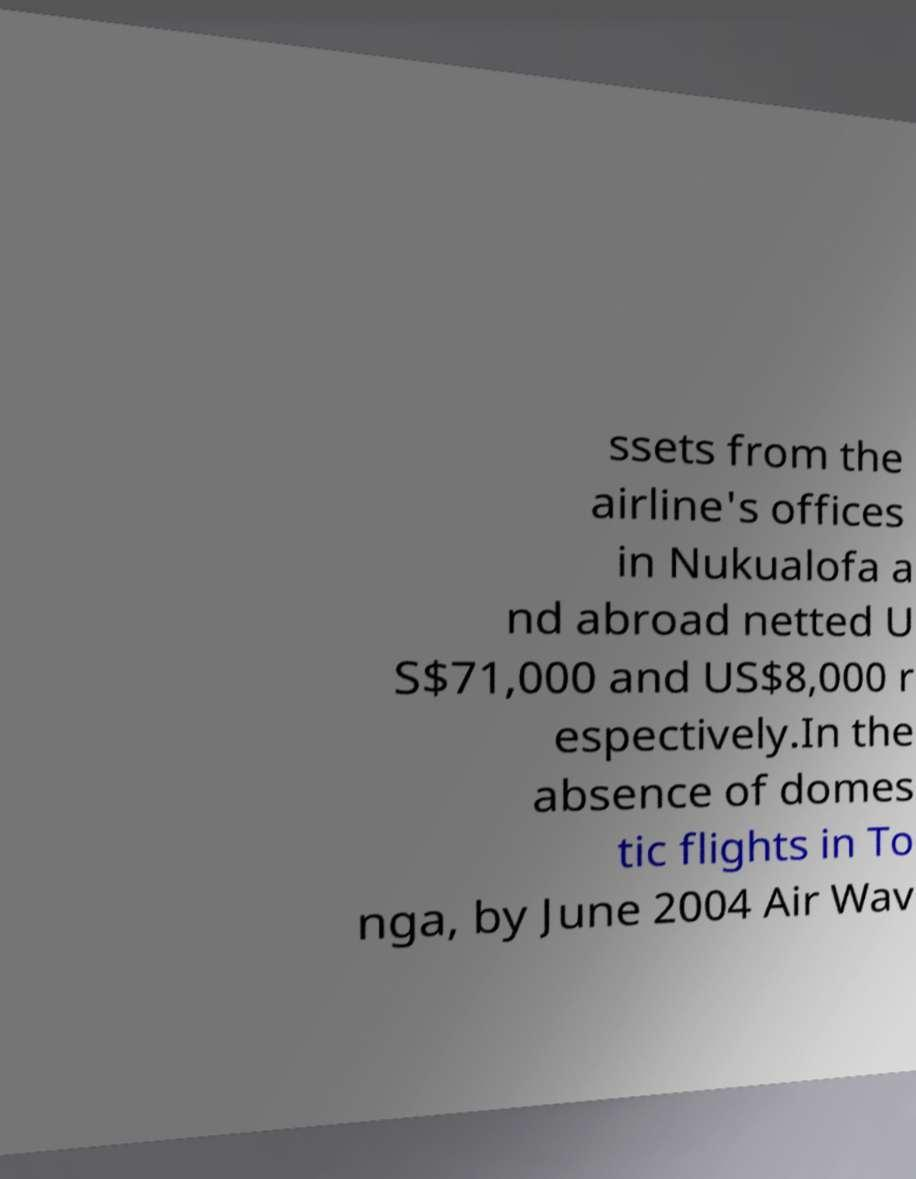For documentation purposes, I need the text within this image transcribed. Could you provide that? ssets from the airline's offices in Nukualofa a nd abroad netted U S$71,000 and US$8,000 r espectively.In the absence of domes tic flights in To nga, by June 2004 Air Wav 